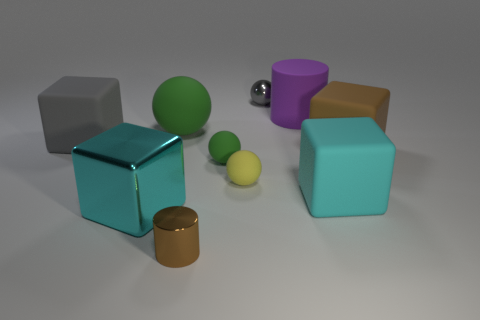Can you tell me how many objects are in the image and describe their shapes? Certainly! There are seven objects in the image. Starting from the left, there's a matte grey cube, a shiny green sphere, a cylindrical gold-colored object, another cube that appears to be teal with a slightly glossy finish, a small matte yellow sphere, a matte pale yellow sphere smaller than the last, and finally, a purple cup-shaped object with a matte finish. 